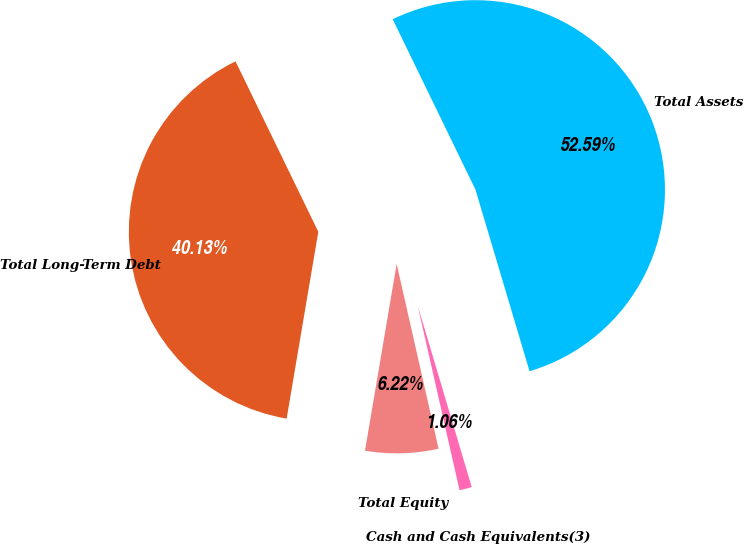Convert chart to OTSL. <chart><loc_0><loc_0><loc_500><loc_500><pie_chart><fcel>Cash and Cash Equivalents(3)<fcel>Total Assets<fcel>Total Long-Term Debt<fcel>Total Equity<nl><fcel>1.06%<fcel>52.59%<fcel>40.13%<fcel>6.22%<nl></chart> 